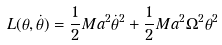<formula> <loc_0><loc_0><loc_500><loc_500>L ( \theta , \dot { \theta } ) = \frac { 1 } { 2 } M a ^ { 2 } \dot { \theta } ^ { 2 } + \frac { 1 } { 2 } M a ^ { 2 } \Omega ^ { 2 } \theta ^ { 2 }</formula> 